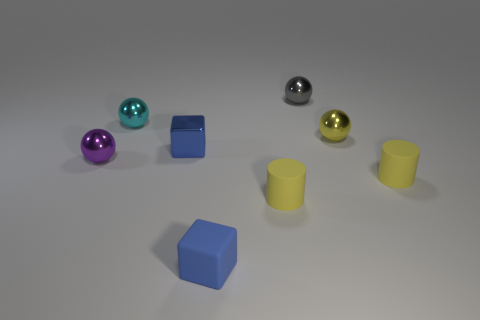Subtract all cyan metallic spheres. How many spheres are left? 3 Add 1 brown shiny objects. How many objects exist? 9 Subtract all yellow balls. How many balls are left? 3 Subtract 0 red spheres. How many objects are left? 8 Subtract all cubes. How many objects are left? 6 Subtract 4 balls. How many balls are left? 0 Subtract all brown cylinders. Subtract all brown blocks. How many cylinders are left? 2 Subtract all purple spheres. How many green cylinders are left? 0 Subtract all big cyan rubber things. Subtract all cyan metallic spheres. How many objects are left? 7 Add 1 tiny yellow matte things. How many tiny yellow matte things are left? 3 